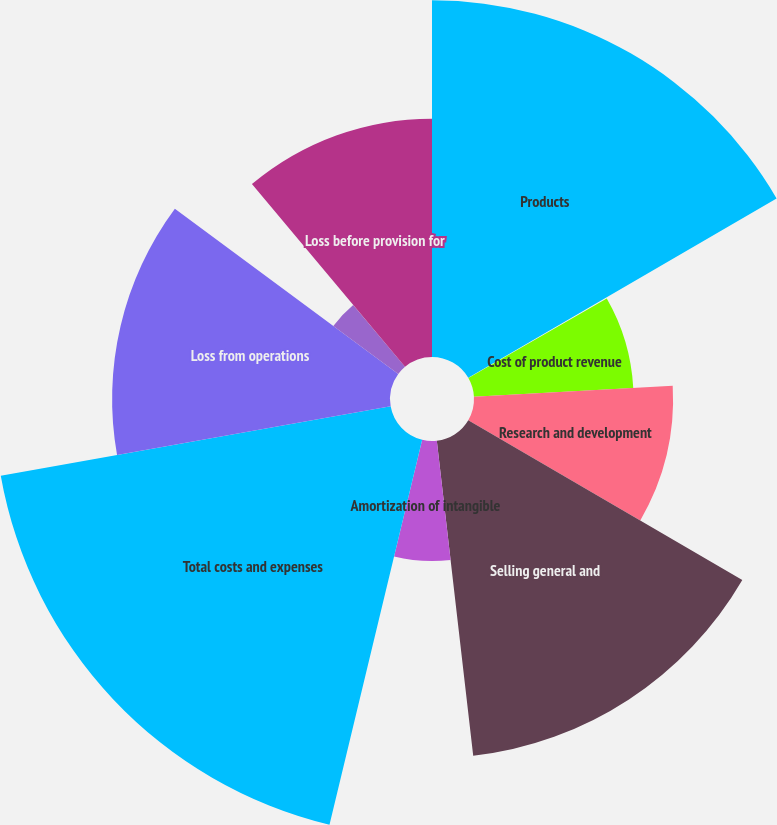Convert chart. <chart><loc_0><loc_0><loc_500><loc_500><pie_chart><fcel>Products<fcel>Funded research and<fcel>Cost of product revenue<fcel>Research and development<fcel>Selling general and<fcel>Amortization of intangible<fcel>Total costs and expenses<fcel>Loss from operations<fcel>Investment income net<fcel>Loss before provision for<nl><fcel>16.61%<fcel>0.09%<fcel>7.43%<fcel>9.27%<fcel>14.77%<fcel>5.59%<fcel>18.44%<fcel>12.94%<fcel>3.76%<fcel>11.1%<nl></chart> 